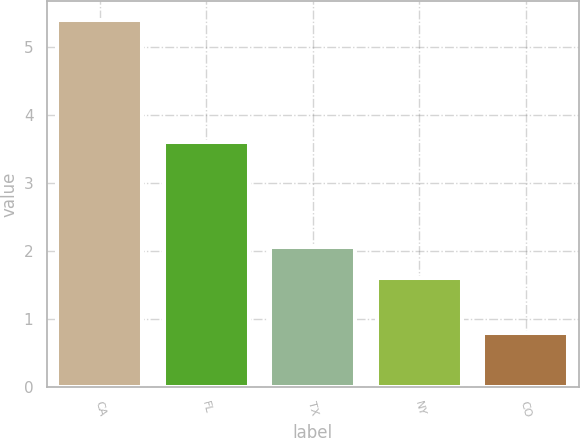<chart> <loc_0><loc_0><loc_500><loc_500><bar_chart><fcel>CA<fcel>FL<fcel>TX<fcel>NY<fcel>CO<nl><fcel>5.4<fcel>3.6<fcel>2.06<fcel>1.6<fcel>0.8<nl></chart> 